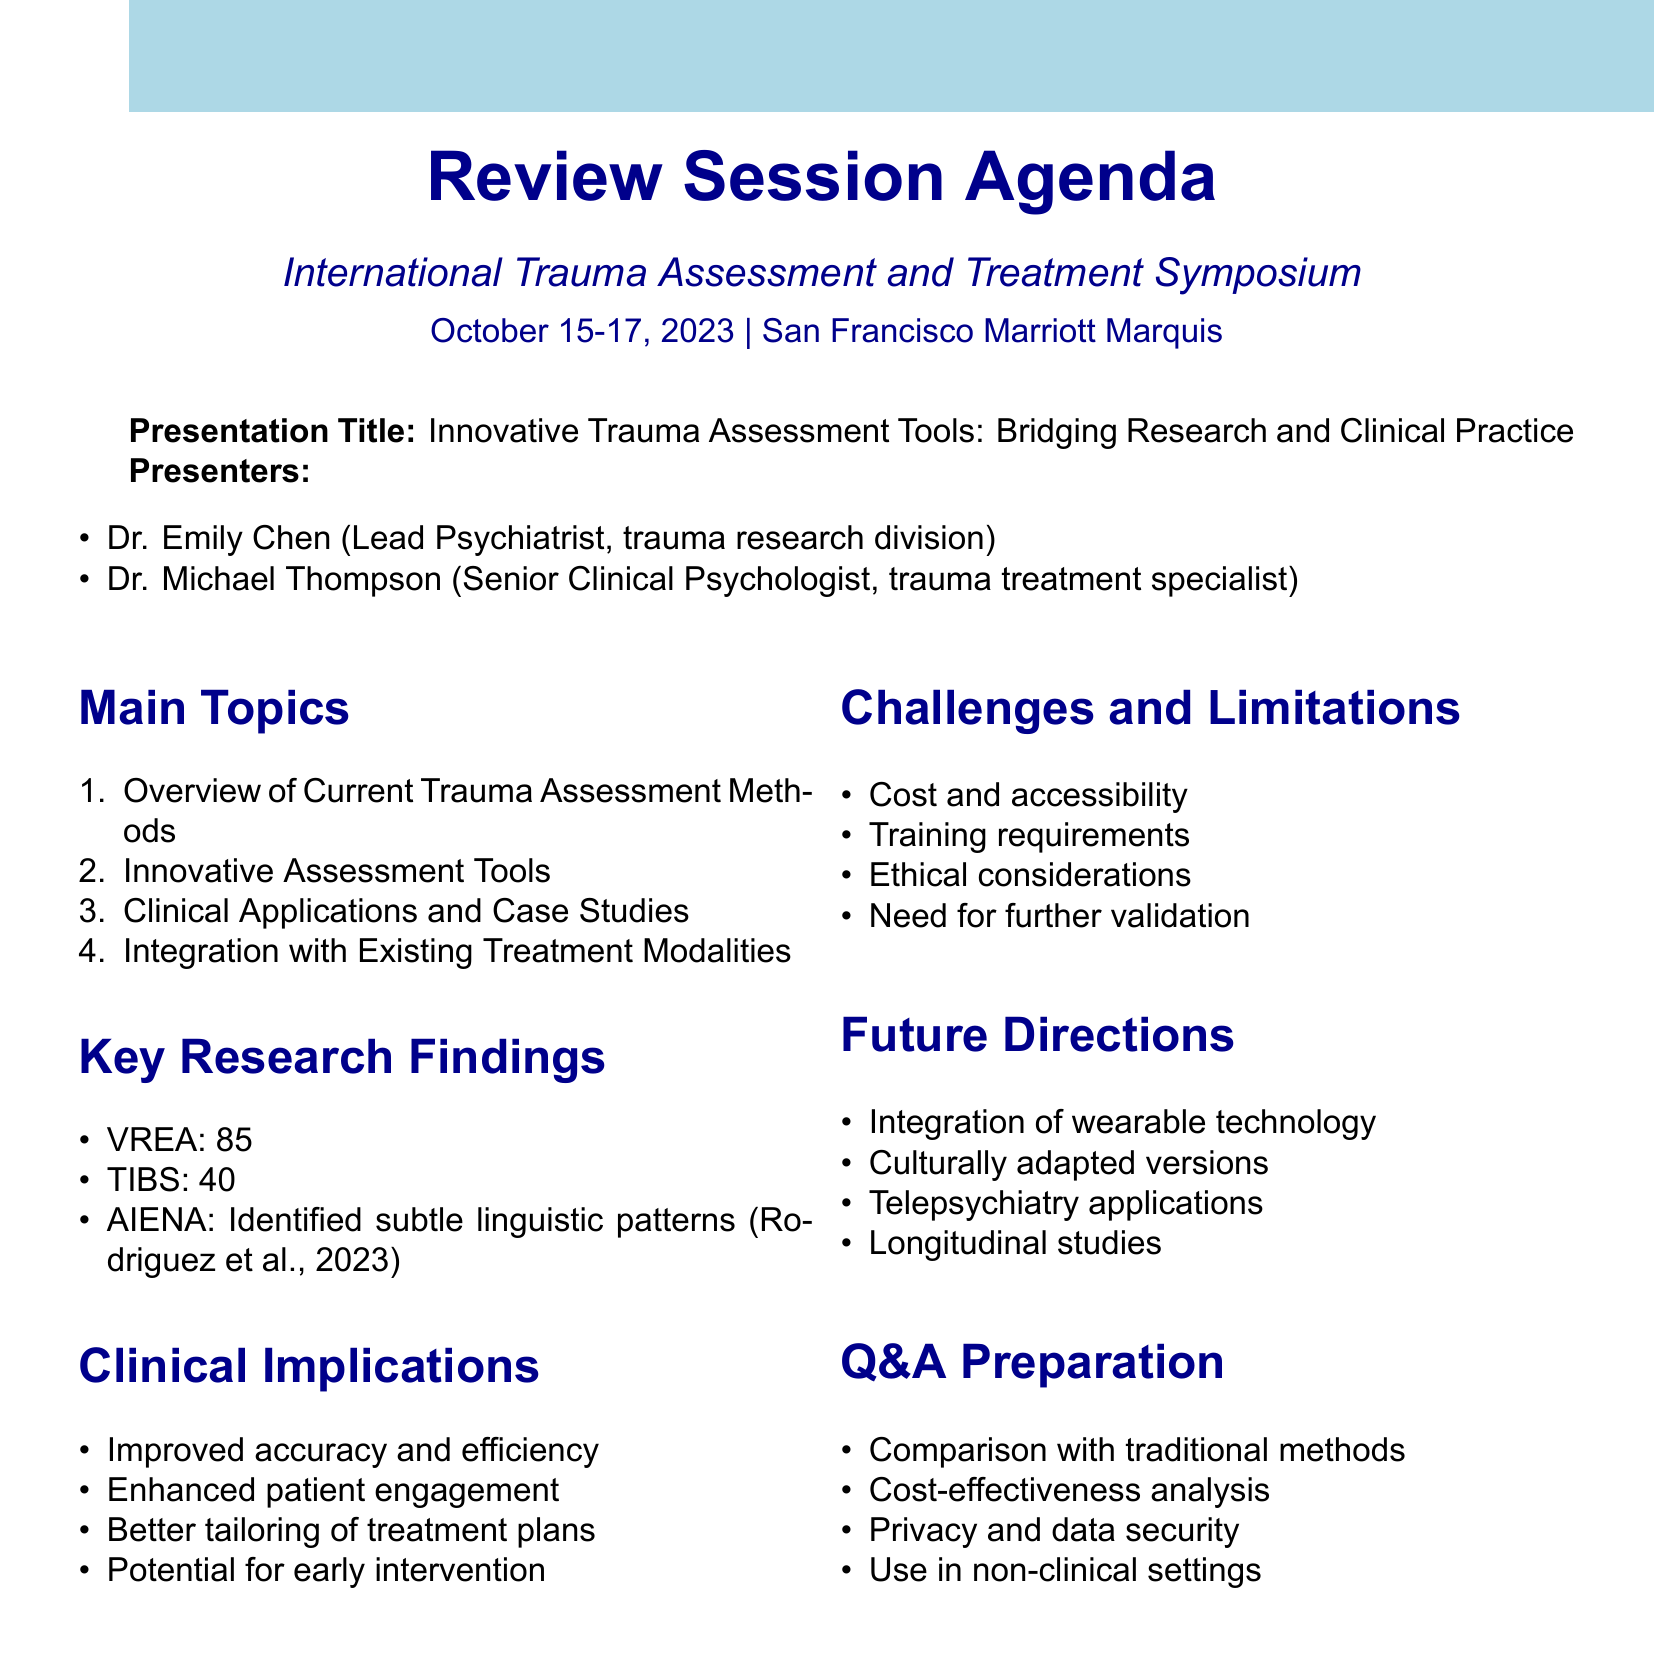What is the name of the symposium? The name of the symposium is stated in the conference details section of the document.
Answer: International Trauma Assessment and Treatment Symposium Who is the lead psychiatrist presenting? The document specifies the presenters and their roles clearly, including the lead psychiatrist.
Answer: Dr. Emily Chen What is one of the innovative assessment tools mentioned? The section on innovative assessment tools lists specific tools used for trauma assessment.
Answer: Virtual Reality Exposure Assessment (VREA) What percentage accuracy did VREA achieve in PTSD diagnosis? The key research findings section provides detailed statistics about the accuracy of assessment tools.
Answer: 85% What is a clinical implication of the new assessment tools? The clinical implications section outlines the benefits related to the implementation of new trauma assessment methods.
Answer: Improved accuracy and efficiency in trauma assessment What is a challenge mentioned regarding new assessment technologies? The challenges and limitations section lists potential obstacles faced in adopting new technologies.
Answer: Cost and accessibility of new technologies What is one future direction mentioned for trauma assessment tools? The future directions section anticipates advancements in trauma assessment methodologies and their applications.
Answer: Integration of wearable technology for real-time symptom monitoring What is one of the subtopics in the overview of current trauma assessment methods? The main topics section outlines different areas of discussion, including subtopics under each main topic.
Answer: Structured Clinical Interviews (e.g., CAPS-5) 